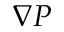Convert formula to latex. <formula><loc_0><loc_0><loc_500><loc_500>\nabla P</formula> 